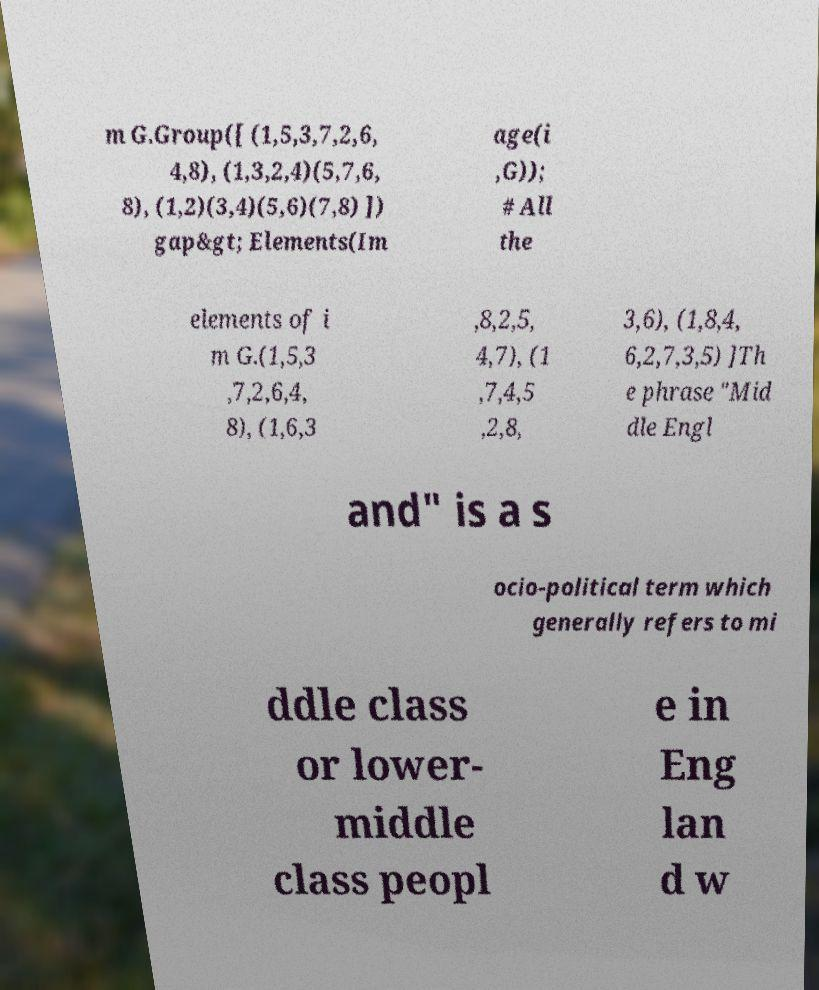Please identify and transcribe the text found in this image. m G.Group([ (1,5,3,7,2,6, 4,8), (1,3,2,4)(5,7,6, 8), (1,2)(3,4)(5,6)(7,8) ]) gap&gt; Elements(Im age(i ,G)); # All the elements of i m G.(1,5,3 ,7,2,6,4, 8), (1,6,3 ,8,2,5, 4,7), (1 ,7,4,5 ,2,8, 3,6), (1,8,4, 6,2,7,3,5) ]Th e phrase "Mid dle Engl and" is a s ocio-political term which generally refers to mi ddle class or lower- middle class peopl e in Eng lan d w 